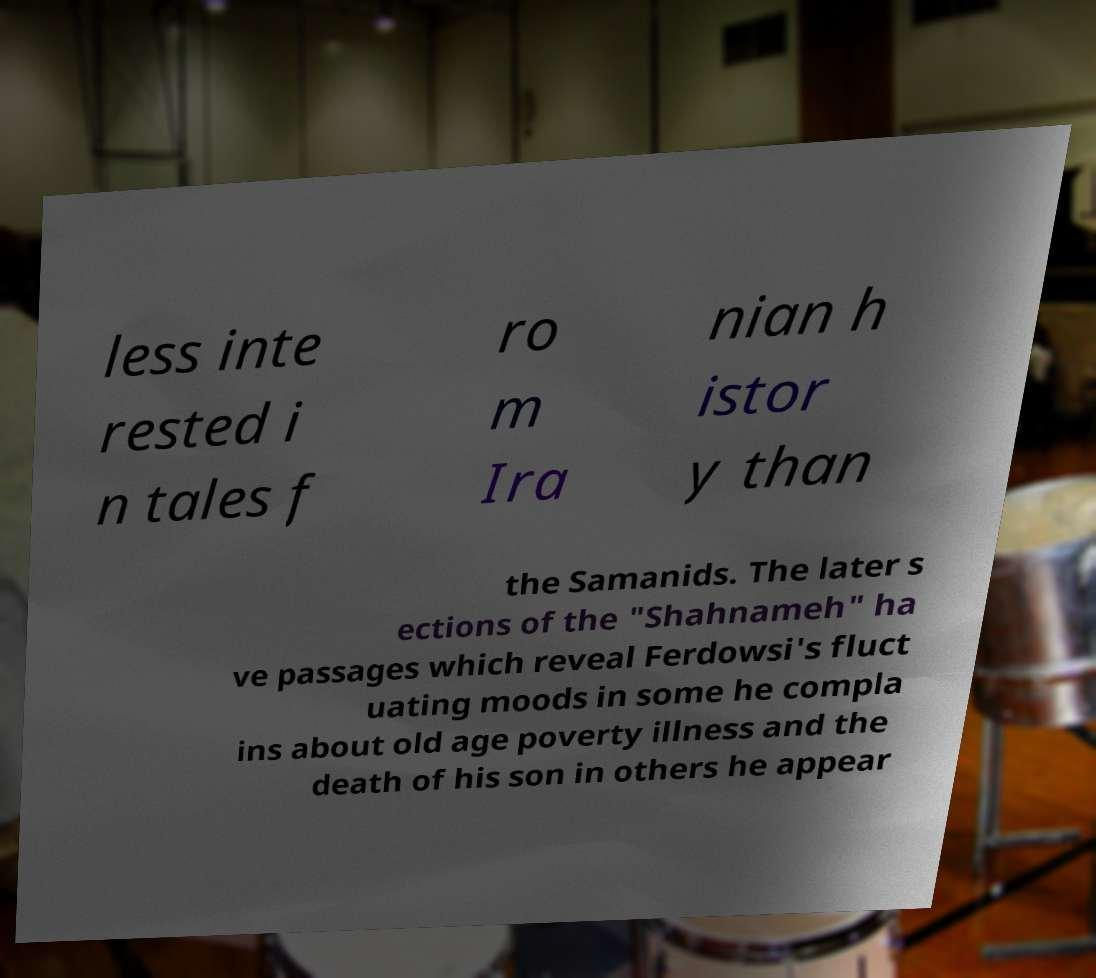Please read and relay the text visible in this image. What does it say? less inte rested i n tales f ro m Ira nian h istor y than the Samanids. The later s ections of the "Shahnameh" ha ve passages which reveal Ferdowsi's fluct uating moods in some he compla ins about old age poverty illness and the death of his son in others he appear 